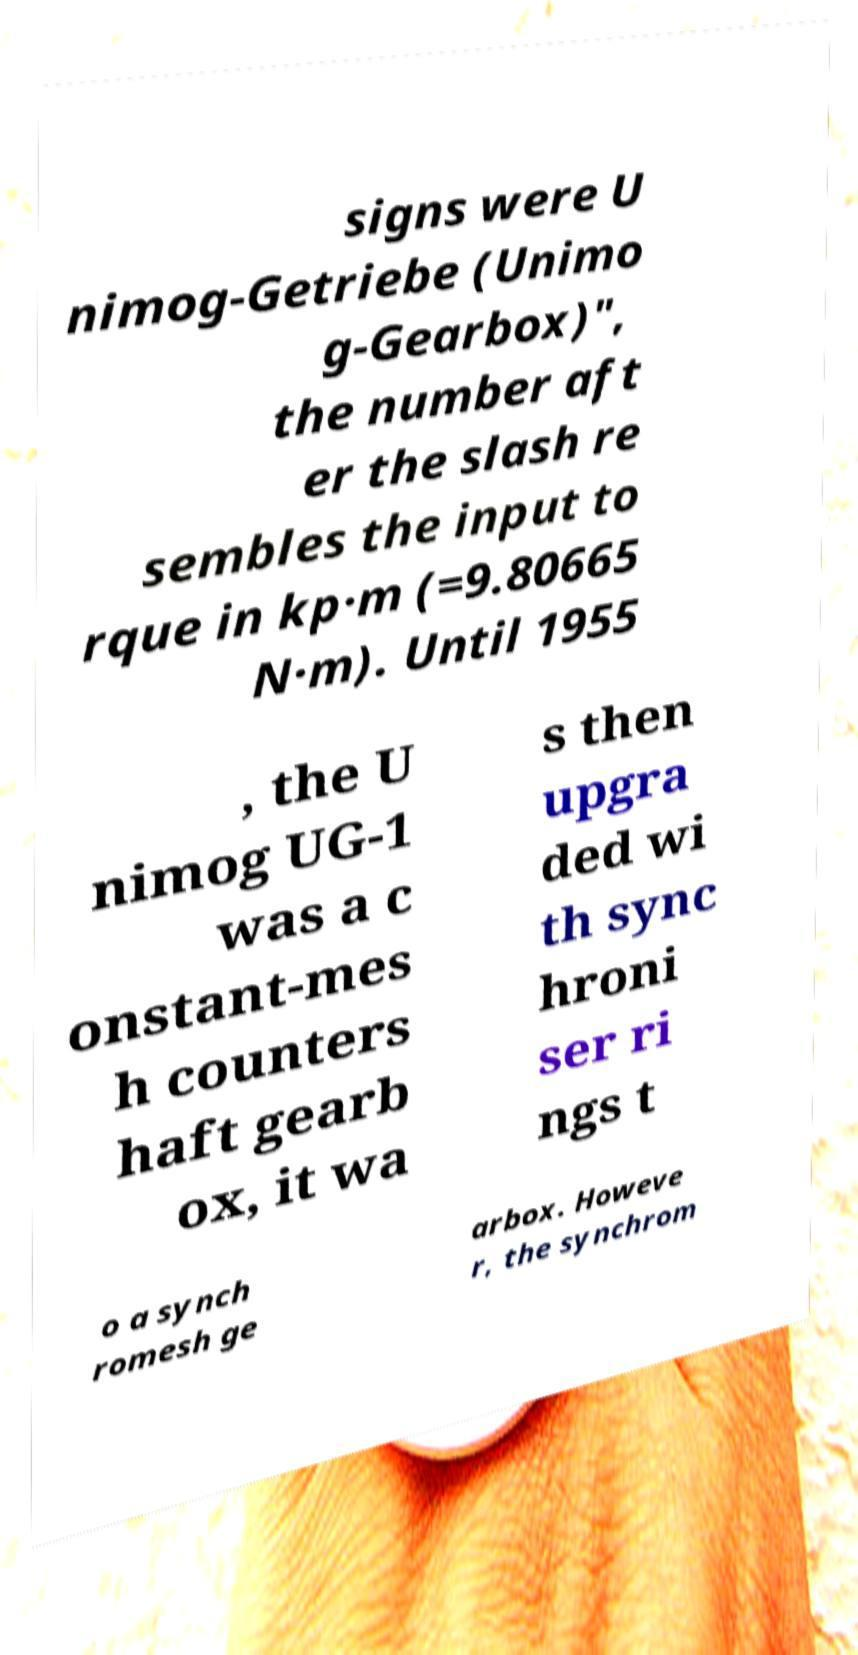There's text embedded in this image that I need extracted. Can you transcribe it verbatim? signs were U nimog-Getriebe (Unimo g-Gearbox)", the number aft er the slash re sembles the input to rque in kp·m (=9.80665 N·m). Until 1955 , the U nimog UG-1 was a c onstant-mes h counters haft gearb ox, it wa s then upgra ded wi th sync hroni ser ri ngs t o a synch romesh ge arbox. Howeve r, the synchrom 